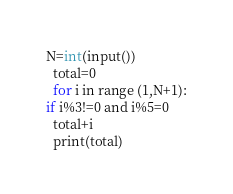Convert code to text. <code><loc_0><loc_0><loc_500><loc_500><_C_>N=int(input())
  total=0
  for i in range (1,N+1):
if i%3!=0 and i%5=0
  total+i
  print(total)</code> 